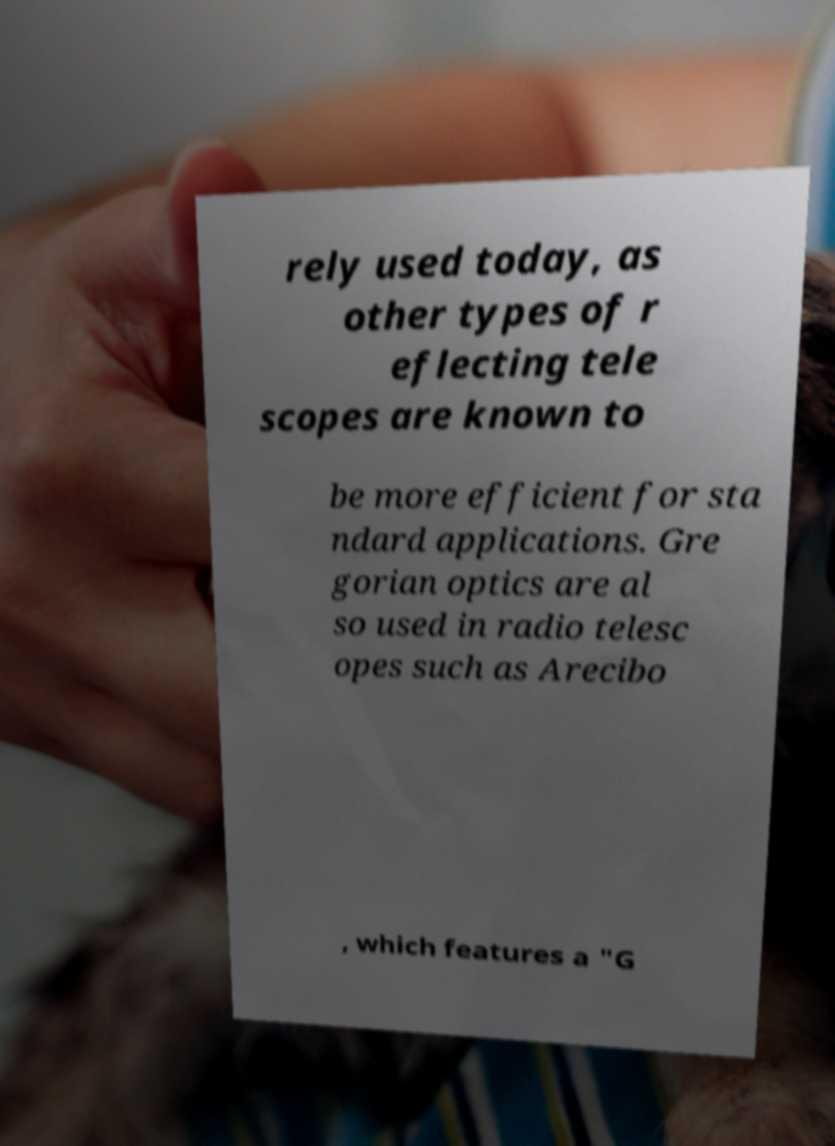For documentation purposes, I need the text within this image transcribed. Could you provide that? rely used today, as other types of r eflecting tele scopes are known to be more efficient for sta ndard applications. Gre gorian optics are al so used in radio telesc opes such as Arecibo , which features a "G 